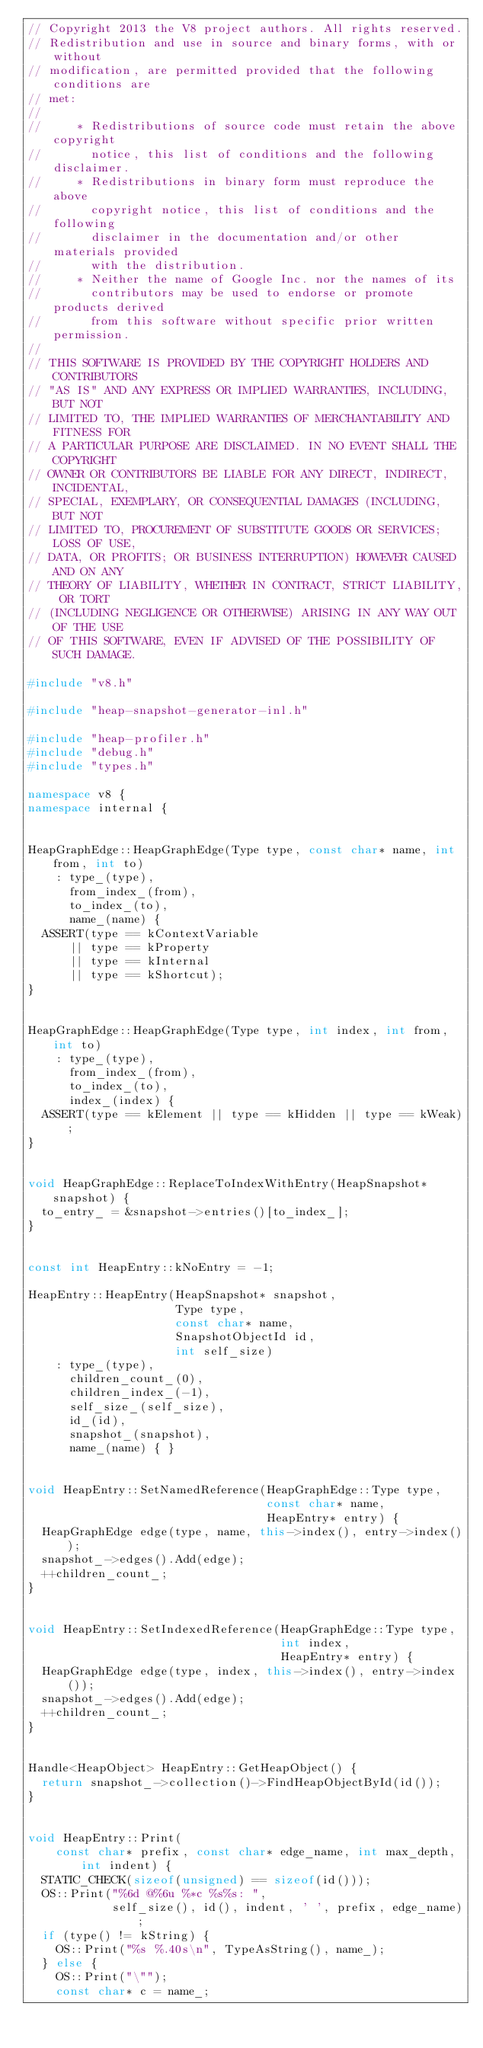Convert code to text. <code><loc_0><loc_0><loc_500><loc_500><_C++_>// Copyright 2013 the V8 project authors. All rights reserved.
// Redistribution and use in source and binary forms, with or without
// modification, are permitted provided that the following conditions are
// met:
//
//     * Redistributions of source code must retain the above copyright
//       notice, this list of conditions and the following disclaimer.
//     * Redistributions in binary form must reproduce the above
//       copyright notice, this list of conditions and the following
//       disclaimer in the documentation and/or other materials provided
//       with the distribution.
//     * Neither the name of Google Inc. nor the names of its
//       contributors may be used to endorse or promote products derived
//       from this software without specific prior written permission.
//
// THIS SOFTWARE IS PROVIDED BY THE COPYRIGHT HOLDERS AND CONTRIBUTORS
// "AS IS" AND ANY EXPRESS OR IMPLIED WARRANTIES, INCLUDING, BUT NOT
// LIMITED TO, THE IMPLIED WARRANTIES OF MERCHANTABILITY AND FITNESS FOR
// A PARTICULAR PURPOSE ARE DISCLAIMED. IN NO EVENT SHALL THE COPYRIGHT
// OWNER OR CONTRIBUTORS BE LIABLE FOR ANY DIRECT, INDIRECT, INCIDENTAL,
// SPECIAL, EXEMPLARY, OR CONSEQUENTIAL DAMAGES (INCLUDING, BUT NOT
// LIMITED TO, PROCUREMENT OF SUBSTITUTE GOODS OR SERVICES; LOSS OF USE,
// DATA, OR PROFITS; OR BUSINESS INTERRUPTION) HOWEVER CAUSED AND ON ANY
// THEORY OF LIABILITY, WHETHER IN CONTRACT, STRICT LIABILITY, OR TORT
// (INCLUDING NEGLIGENCE OR OTHERWISE) ARISING IN ANY WAY OUT OF THE USE
// OF THIS SOFTWARE, EVEN IF ADVISED OF THE POSSIBILITY OF SUCH DAMAGE.

#include "v8.h"

#include "heap-snapshot-generator-inl.h"

#include "heap-profiler.h"
#include "debug.h"
#include "types.h"

namespace v8 {
namespace internal {


HeapGraphEdge::HeapGraphEdge(Type type, const char* name, int from, int to)
    : type_(type),
      from_index_(from),
      to_index_(to),
      name_(name) {
  ASSERT(type == kContextVariable
      || type == kProperty
      || type == kInternal
      || type == kShortcut);
}


HeapGraphEdge::HeapGraphEdge(Type type, int index, int from, int to)
    : type_(type),
      from_index_(from),
      to_index_(to),
      index_(index) {
  ASSERT(type == kElement || type == kHidden || type == kWeak);
}


void HeapGraphEdge::ReplaceToIndexWithEntry(HeapSnapshot* snapshot) {
  to_entry_ = &snapshot->entries()[to_index_];
}


const int HeapEntry::kNoEntry = -1;

HeapEntry::HeapEntry(HeapSnapshot* snapshot,
                     Type type,
                     const char* name,
                     SnapshotObjectId id,
                     int self_size)
    : type_(type),
      children_count_(0),
      children_index_(-1),
      self_size_(self_size),
      id_(id),
      snapshot_(snapshot),
      name_(name) { }


void HeapEntry::SetNamedReference(HeapGraphEdge::Type type,
                                  const char* name,
                                  HeapEntry* entry) {
  HeapGraphEdge edge(type, name, this->index(), entry->index());
  snapshot_->edges().Add(edge);
  ++children_count_;
}


void HeapEntry::SetIndexedReference(HeapGraphEdge::Type type,
                                    int index,
                                    HeapEntry* entry) {
  HeapGraphEdge edge(type, index, this->index(), entry->index());
  snapshot_->edges().Add(edge);
  ++children_count_;
}


Handle<HeapObject> HeapEntry::GetHeapObject() {
  return snapshot_->collection()->FindHeapObjectById(id());
}


void HeapEntry::Print(
    const char* prefix, const char* edge_name, int max_depth, int indent) {
  STATIC_CHECK(sizeof(unsigned) == sizeof(id()));
  OS::Print("%6d @%6u %*c %s%s: ",
            self_size(), id(), indent, ' ', prefix, edge_name);
  if (type() != kString) {
    OS::Print("%s %.40s\n", TypeAsString(), name_);
  } else {
    OS::Print("\"");
    const char* c = name_;</code> 